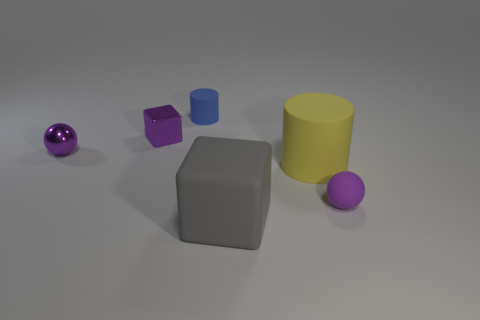There is a purple sphere that is on the right side of the rubber block; does it have the same size as the thing in front of the small purple rubber thing?
Your response must be concise. No. The purple object that is the same material as the large cylinder is what shape?
Your answer should be very brief. Sphere. Is there anything else that has the same shape as the blue matte thing?
Keep it short and to the point. Yes. What is the color of the small ball that is to the right of the object that is to the left of the block that is behind the small purple matte sphere?
Your answer should be compact. Purple. Is the number of purple metallic spheres that are behind the tiny blue rubber cylinder less than the number of large things that are in front of the purple rubber thing?
Keep it short and to the point. Yes. Do the purple matte thing and the gray object have the same shape?
Give a very brief answer. No. How many yellow rubber cylinders have the same size as the blue matte thing?
Offer a very short reply. 0. Are there fewer big rubber cylinders that are in front of the big gray thing than spheres?
Provide a succinct answer. Yes. There is a purple sphere that is in front of the tiny sphere that is left of the large yellow rubber cylinder; how big is it?
Your answer should be compact. Small. How many things are purple shiny objects or gray matte cubes?
Ensure brevity in your answer.  3. 